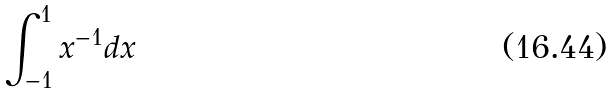<formula> <loc_0><loc_0><loc_500><loc_500>\int _ { - 1 } ^ { 1 } x ^ { - 1 } d x</formula> 